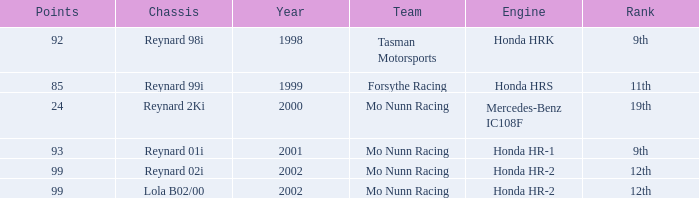What is the total number of points of the honda hr-1 engine? 1.0. 